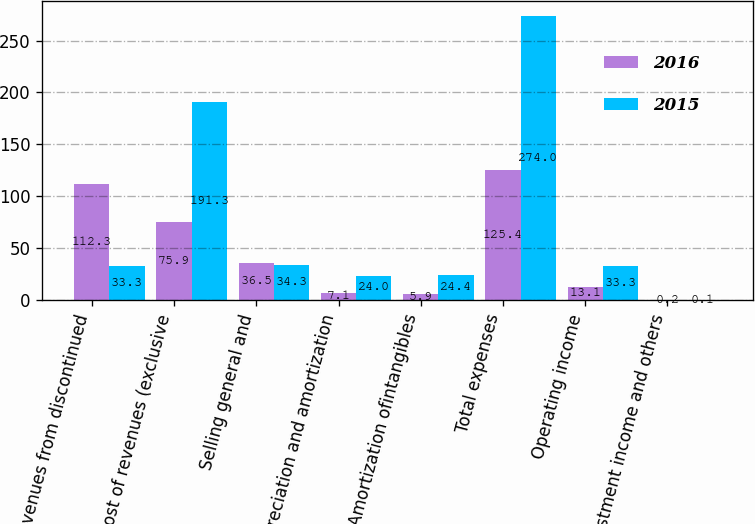Convert chart. <chart><loc_0><loc_0><loc_500><loc_500><stacked_bar_chart><ecel><fcel>Revenues from discontinued<fcel>Cost of revenues (exclusive<fcel>Selling general and<fcel>Depreciation and amortization<fcel>Amortization ofintangibles<fcel>Total expenses<fcel>Operating income<fcel>Investment income and others<nl><fcel>2016<fcel>112.3<fcel>75.9<fcel>36.5<fcel>7.1<fcel>5.9<fcel>125.4<fcel>13.1<fcel>0.2<nl><fcel>2015<fcel>33.3<fcel>191.3<fcel>34.3<fcel>24<fcel>24.4<fcel>274<fcel>33.3<fcel>0.1<nl></chart> 